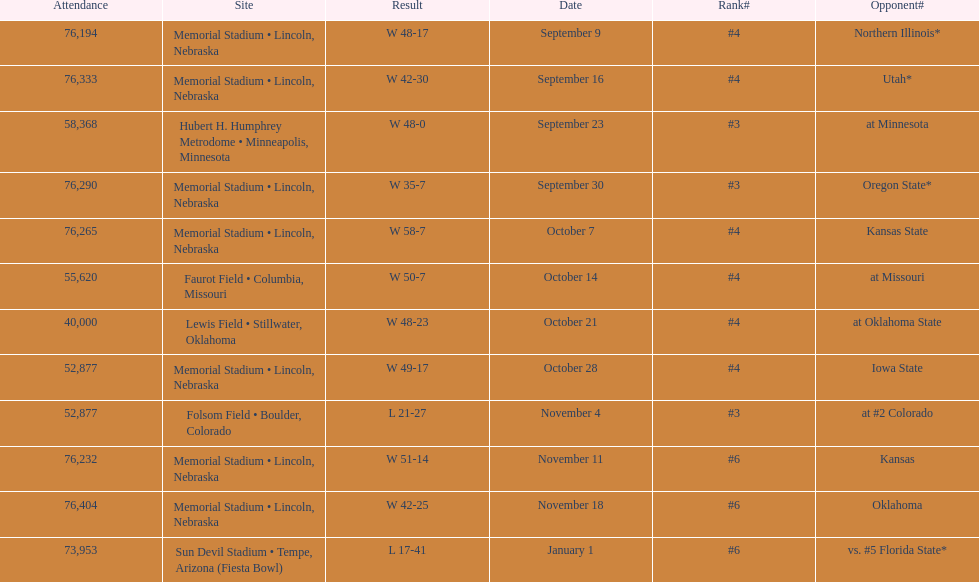How many games did they win by more than 7? 10. Would you mind parsing the complete table? {'header': ['Attendance', 'Site', 'Result', 'Date', 'Rank#', 'Opponent#'], 'rows': [['76,194', 'Memorial Stadium • Lincoln, Nebraska', 'W\xa048-17', 'September 9', '#4', 'Northern Illinois*'], ['76,333', 'Memorial Stadium • Lincoln, Nebraska', 'W\xa042-30', 'September 16', '#4', 'Utah*'], ['58,368', 'Hubert H. Humphrey Metrodome • Minneapolis, Minnesota', 'W\xa048-0', 'September 23', '#3', 'at\xa0Minnesota'], ['76,290', 'Memorial Stadium • Lincoln, Nebraska', 'W\xa035-7', 'September 30', '#3', 'Oregon State*'], ['76,265', 'Memorial Stadium • Lincoln, Nebraska', 'W\xa058-7', 'October 7', '#4', 'Kansas State'], ['55,620', 'Faurot Field • Columbia, Missouri', 'W\xa050-7', 'October 14', '#4', 'at\xa0Missouri'], ['40,000', 'Lewis Field • Stillwater, Oklahoma', 'W\xa048-23', 'October 21', '#4', 'at\xa0Oklahoma State'], ['52,877', 'Memorial Stadium • Lincoln, Nebraska', 'W\xa049-17', 'October 28', '#4', 'Iowa State'], ['52,877', 'Folsom Field • Boulder, Colorado', 'L\xa021-27', 'November 4', '#3', 'at\xa0#2\xa0Colorado'], ['76,232', 'Memorial Stadium • Lincoln, Nebraska', 'W\xa051-14', 'November 11', '#6', 'Kansas'], ['76,404', 'Memorial Stadium • Lincoln, Nebraska', 'W\xa042-25', 'November 18', '#6', 'Oklahoma'], ['73,953', 'Sun Devil Stadium • Tempe, Arizona (Fiesta Bowl)', 'L\xa017-41', 'January 1', '#6', 'vs.\xa0#5\xa0Florida State*']]} 